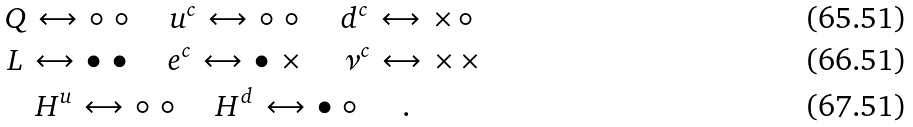<formula> <loc_0><loc_0><loc_500><loc_500>& Q \, \leftrightarrow \, \circ \, \circ \, \quad u ^ { c } \, \leftrightarrow \, \circ \, \circ \, \quad d ^ { c } \, \leftrightarrow \, \times \, \circ \, \\ & L \, \leftrightarrow \, \bullet \, \bullet \, \quad e ^ { c } \, \leftrightarrow \, \bullet \, \times \, \quad \nu ^ { c } \, \leftrightarrow \, \times \, \times \, \\ & \quad H ^ { u } \, \leftrightarrow \, \circ \, \circ \, \quad H ^ { d } \, \leftrightarrow \, \bullet \, \circ \, \quad \, .</formula> 